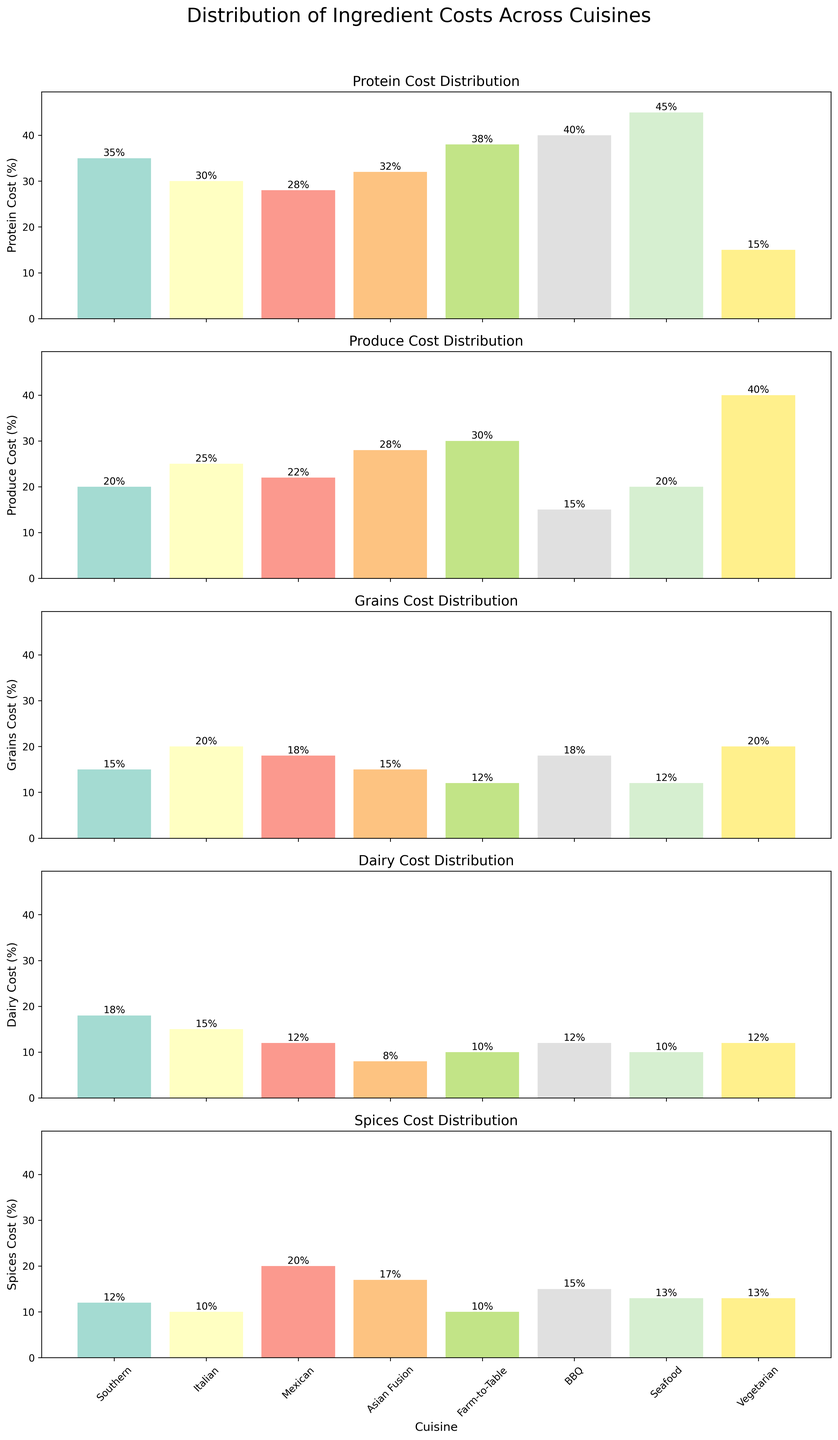What is the title of the figure? The title of the figure is located at the top and it reads "Distribution of Ingredient Costs Across Cuisines".
Answer: Distribution of Ingredient Costs Across Cuisines Which cuisine has the highest cost for protein? The tallest bar under the "Protein Cost Distribution" subplot is for Seafood cuisine, indicating that it has the highest cost for protein.
Answer: Seafood What is the cost percentage for spices in Mexican cuisine? In the subplot labeled "Spices Cost Distribution", the bar for Mexican cuisine reaches the 20% mark, indicating the cost percentage for spices.
Answer: 20% Which two cuisines have the highest and lowest cost for produce? By looking at the "Produce Cost Distribution" subplot, the highest bar is for Vegetarian cuisine at 40%, and the lowest is for BBQ cuisine at 15%.
Answer: Highest: Vegetarian, Lowest: BBQ How does the dairy cost of Asian Fusion compare to that of Southern cuisine? In the "Dairy Cost Distribution" subplot, the bar for Southern cuisine is at 18%, and the bar for Asian Fusion is at 8%, showing that Southern cuisine has a higher dairy cost.
Answer: Southern is higher What is the average grain cost across all cuisines? In the "Grains Cost Distribution" subplot, the grain costs are 15, 20, 18, 15, 12, 18, 12, 20. Summing these gives 130, and dividing by the 8 cuisines gives an average of 16.25%.
Answer: 16.25% Which cuisine spends more on protein, Farm-to-Table or Southern? By how much? In the "Protein Cost Distribution" subplot, Farm-to-Table has a cost of 38%, and Southern has 35%. Farm-to-Table spends 3% more on protein.
Answer: Farm-to-Table by 3% What is the total ingredient cost percentage for Italian cuisine? Add the percentages in the Italian row from each subplot (30 for Protein, 25 for Produce, 20 for Grains, 15 for Dairy, and 10 for Spices): 30 + 25 + 20 + 15 + 10 = 100.
Answer: 100% Which cuisine has the second highest cost for spices? In the "Spices Cost Distribution" subplot, the tallest bar is for Mexican cuisine (20%). The second tallest bar is for Asian Fusion cuisine at 17%.
Answer: Asian Fusion Which cuisine has the lowest cost for dairy and what is its percentage? In the "Dairy Cost Distribution" subplot, the lowest bar is for Asian Fusion cuisine at 8%, indicating it has the lowest dairy cost.
Answer: Asian Fusion, 8% 